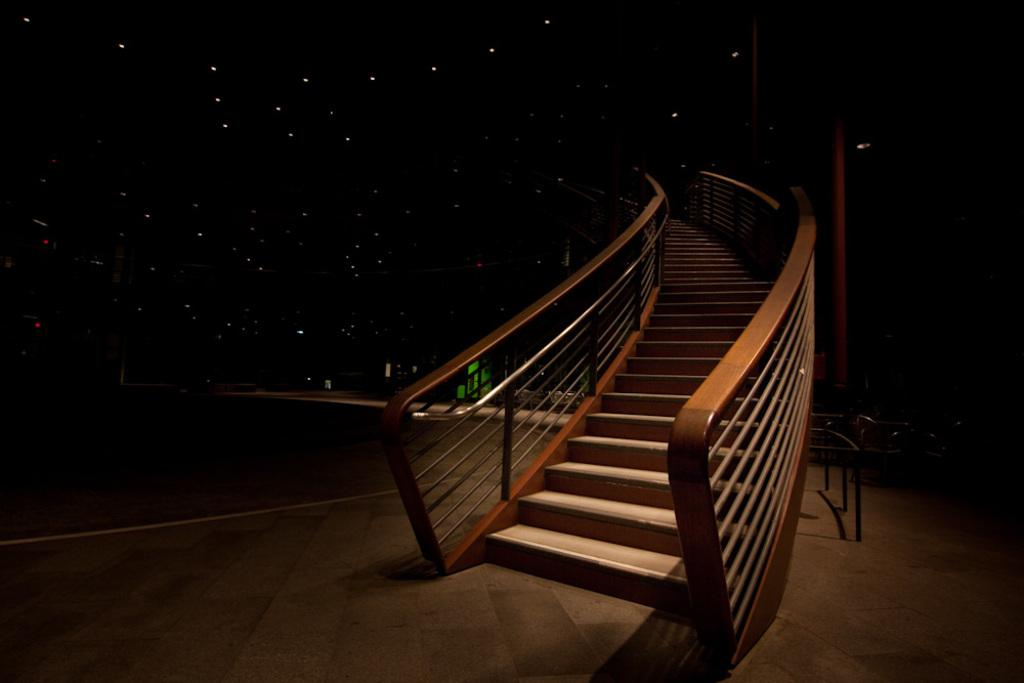What type of structure is present in the image? There are stairs in the image. What color is the background of the image? The background of the image is black. What can be seen illuminating the area in the image? There are lights visible in the image. How does the tiger affect the stairs in the image? There is no tiger present in the image, so it cannot affect the stairs. 